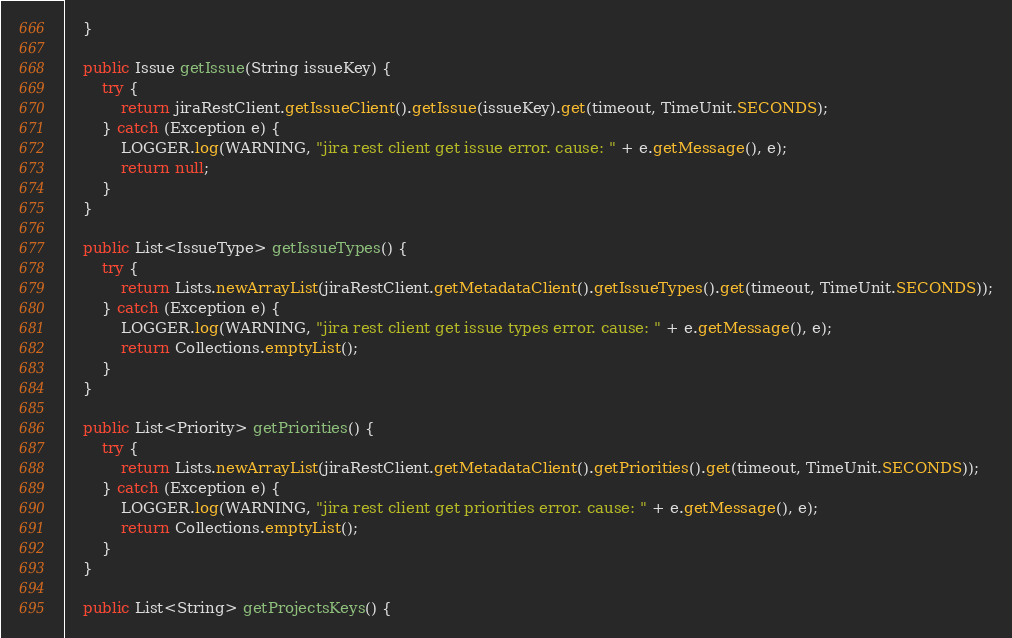<code> <loc_0><loc_0><loc_500><loc_500><_Java_>    }
  
    public Issue getIssue(String issueKey) {
        try {
            return jiraRestClient.getIssueClient().getIssue(issueKey).get(timeout, TimeUnit.SECONDS);
        } catch (Exception e) {
            LOGGER.log(WARNING, "jira rest client get issue error. cause: " + e.getMessage(), e);
            return null;
        }
    }

    public List<IssueType> getIssueTypes() {
        try {
            return Lists.newArrayList(jiraRestClient.getMetadataClient().getIssueTypes().get(timeout, TimeUnit.SECONDS));
        } catch (Exception e) {
            LOGGER.log(WARNING, "jira rest client get issue types error. cause: " + e.getMessage(), e);
            return Collections.emptyList();
        }
    }

    public List<Priority> getPriorities() {
        try {
            return Lists.newArrayList(jiraRestClient.getMetadataClient().getPriorities().get(timeout, TimeUnit.SECONDS));
        } catch (Exception e) {
            LOGGER.log(WARNING, "jira rest client get priorities error. cause: " + e.getMessage(), e);
            return Collections.emptyList();
        }
    }

    public List<String> getProjectsKeys() {</code> 